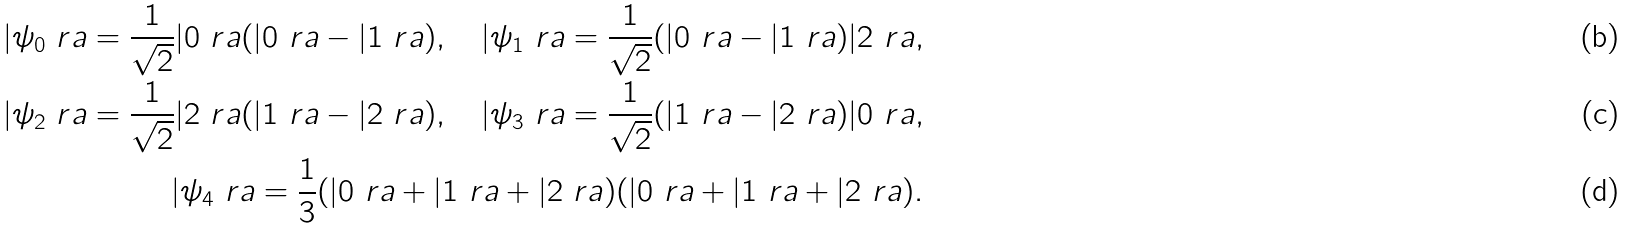<formula> <loc_0><loc_0><loc_500><loc_500>| \psi _ { 0 } \ r a = \frac { 1 } { \sqrt { 2 } } | 0 \ r a ( | 0 \ r a - | 1 \ r a ) , \quad | \psi _ { 1 } \ r a = \frac { 1 } { \sqrt { 2 } } ( | 0 \ r a - | 1 \ r a ) | 2 \ r a , \\ | \psi _ { 2 } \ r a = \frac { 1 } { \sqrt { 2 } } | 2 \ r a ( | 1 \ r a - | 2 \ r a ) , \quad | \psi _ { 3 } \ r a = \frac { 1 } { \sqrt { 2 } } ( | 1 \ r a - | 2 \ r a ) | 0 \ r a , \\ | \psi _ { 4 } \ r a = \frac { 1 } { 3 } ( | 0 \ r a + | 1 \ r a + | 2 \ r a ) ( | 0 \ r a + | 1 \ r a + | 2 \ r a ) .</formula> 